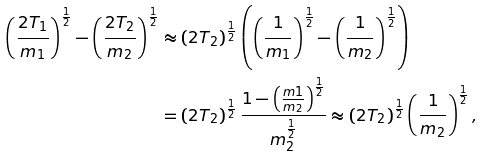<formula> <loc_0><loc_0><loc_500><loc_500>\left ( \frac { 2 T _ { 1 } } { m _ { 1 } } \right ) ^ { \frac { 1 } { 2 } } - \left ( \frac { 2 T _ { 2 } } { m _ { 2 } } \right ) ^ { \frac { 1 } { 2 } } & \approx \left ( 2 T _ { 2 } \right ) ^ { \frac { 1 } { 2 } } \left ( \left ( \frac { 1 } { m _ { 1 } } \right ) ^ { \frac { 1 } { 2 } } - \left ( \frac { 1 } { m _ { 2 } } \right ) ^ { \frac { 1 } { 2 } } \right ) \\ & = \left ( 2 T _ { 2 } \right ) ^ { \frac { 1 } { 2 } } \frac { 1 - \left ( \frac { m 1 } { m _ { 2 } } \right ) ^ { \frac { 1 } { 2 } } } { m _ { 2 } ^ { \frac { 1 } { 2 } } } \approx \left ( 2 T _ { 2 } \right ) ^ { \frac { 1 } { 2 } } \left ( \frac { 1 } { m _ { 2 } } \right ) ^ { \frac { 1 } { 2 } } ,</formula> 